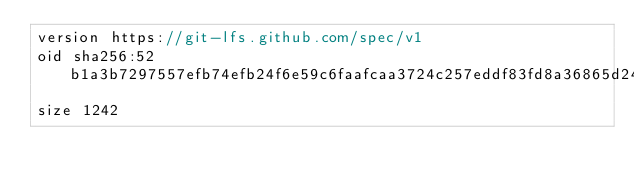Convert code to text. <code><loc_0><loc_0><loc_500><loc_500><_C++_>version https://git-lfs.github.com/spec/v1
oid sha256:52b1a3b7297557efb74efb24f6e59c6faafcaa3724c257eddf83fd8a36865d24
size 1242
</code> 